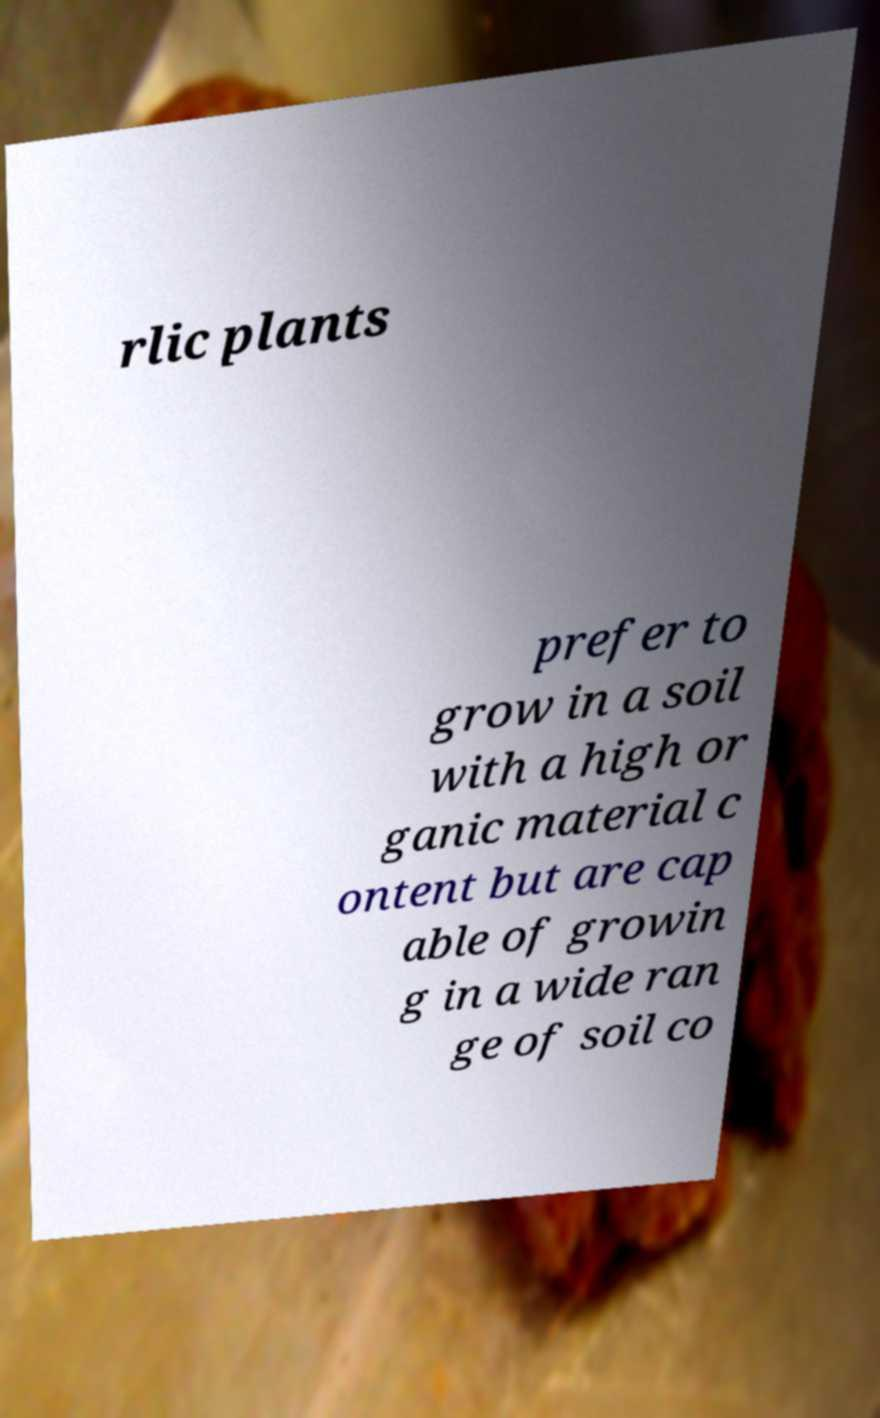For documentation purposes, I need the text within this image transcribed. Could you provide that? rlic plants prefer to grow in a soil with a high or ganic material c ontent but are cap able of growin g in a wide ran ge of soil co 